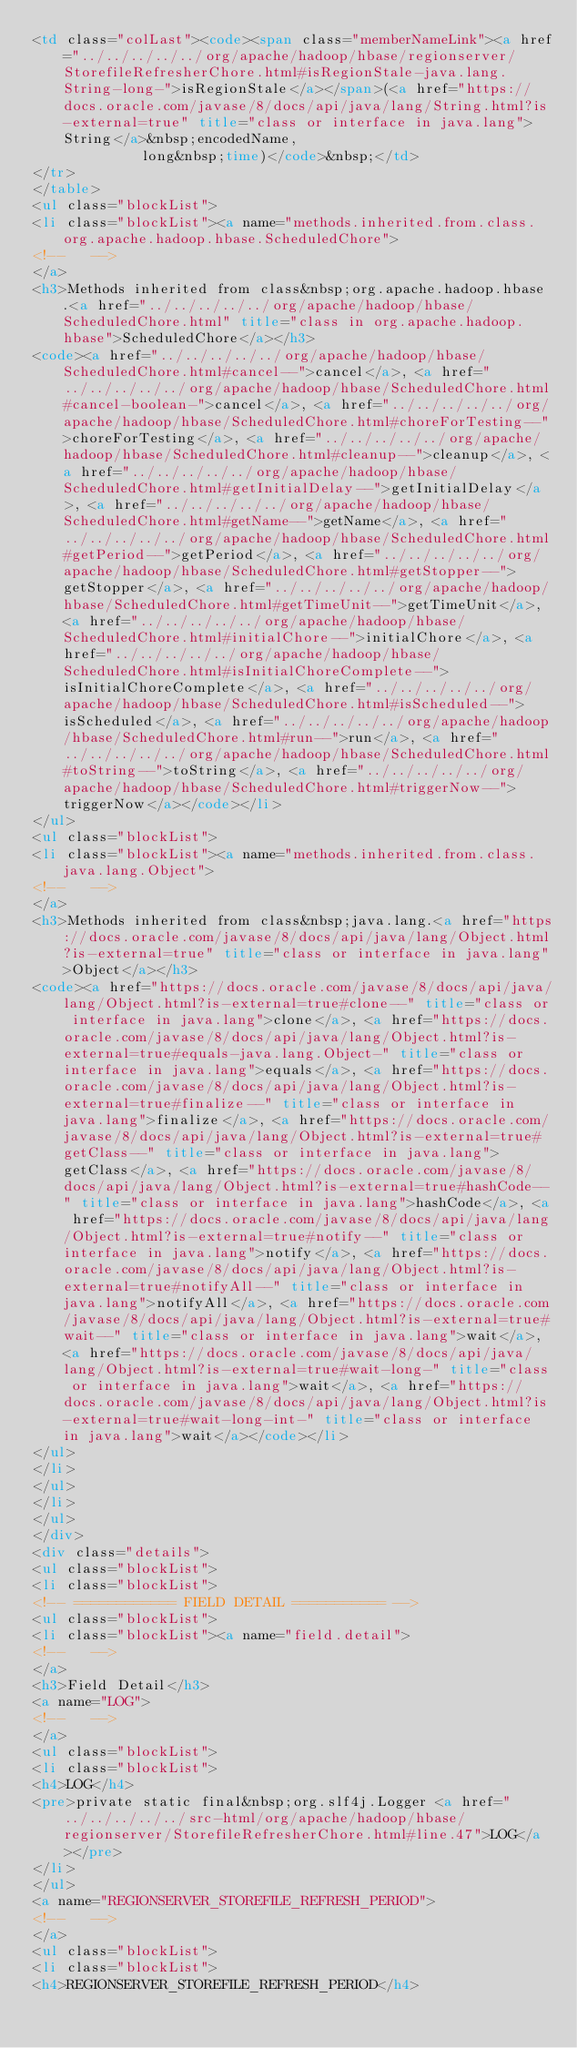<code> <loc_0><loc_0><loc_500><loc_500><_HTML_><td class="colLast"><code><span class="memberNameLink"><a href="../../../../../org/apache/hadoop/hbase/regionserver/StorefileRefresherChore.html#isRegionStale-java.lang.String-long-">isRegionStale</a></span>(<a href="https://docs.oracle.com/javase/8/docs/api/java/lang/String.html?is-external=true" title="class or interface in java.lang">String</a>&nbsp;encodedName,
             long&nbsp;time)</code>&nbsp;</td>
</tr>
</table>
<ul class="blockList">
<li class="blockList"><a name="methods.inherited.from.class.org.apache.hadoop.hbase.ScheduledChore">
<!--   -->
</a>
<h3>Methods inherited from class&nbsp;org.apache.hadoop.hbase.<a href="../../../../../org/apache/hadoop/hbase/ScheduledChore.html" title="class in org.apache.hadoop.hbase">ScheduledChore</a></h3>
<code><a href="../../../../../org/apache/hadoop/hbase/ScheduledChore.html#cancel--">cancel</a>, <a href="../../../../../org/apache/hadoop/hbase/ScheduledChore.html#cancel-boolean-">cancel</a>, <a href="../../../../../org/apache/hadoop/hbase/ScheduledChore.html#choreForTesting--">choreForTesting</a>, <a href="../../../../../org/apache/hadoop/hbase/ScheduledChore.html#cleanup--">cleanup</a>, <a href="../../../../../org/apache/hadoop/hbase/ScheduledChore.html#getInitialDelay--">getInitialDelay</a>, <a href="../../../../../org/apache/hadoop/hbase/ScheduledChore.html#getName--">getName</a>, <a href="../../../../../org/apache/hadoop/hbase/ScheduledChore.html#getPeriod--">getPeriod</a>, <a href="../../../../../org/apache/hadoop/hbase/ScheduledChore.html#getStopper--">getStopper</a>, <a href="../../../../../org/apache/hadoop/hbase/ScheduledChore.html#getTimeUnit--">getTimeUnit</a>, <a href="../../../../../org/apache/hadoop/hbase/ScheduledChore.html#initialChore--">initialChore</a>, <a href="../../../../../org/apache/hadoop/hbase/ScheduledChore.html#isInitialChoreComplete--">isInitialChoreComplete</a>, <a href="../../../../../org/apache/hadoop/hbase/ScheduledChore.html#isScheduled--">isScheduled</a>, <a href="../../../../../org/apache/hadoop/hbase/ScheduledChore.html#run--">run</a>, <a href="../../../../../org/apache/hadoop/hbase/ScheduledChore.html#toString--">toString</a>, <a href="../../../../../org/apache/hadoop/hbase/ScheduledChore.html#triggerNow--">triggerNow</a></code></li>
</ul>
<ul class="blockList">
<li class="blockList"><a name="methods.inherited.from.class.java.lang.Object">
<!--   -->
</a>
<h3>Methods inherited from class&nbsp;java.lang.<a href="https://docs.oracle.com/javase/8/docs/api/java/lang/Object.html?is-external=true" title="class or interface in java.lang">Object</a></h3>
<code><a href="https://docs.oracle.com/javase/8/docs/api/java/lang/Object.html?is-external=true#clone--" title="class or interface in java.lang">clone</a>, <a href="https://docs.oracle.com/javase/8/docs/api/java/lang/Object.html?is-external=true#equals-java.lang.Object-" title="class or interface in java.lang">equals</a>, <a href="https://docs.oracle.com/javase/8/docs/api/java/lang/Object.html?is-external=true#finalize--" title="class or interface in java.lang">finalize</a>, <a href="https://docs.oracle.com/javase/8/docs/api/java/lang/Object.html?is-external=true#getClass--" title="class or interface in java.lang">getClass</a>, <a href="https://docs.oracle.com/javase/8/docs/api/java/lang/Object.html?is-external=true#hashCode--" title="class or interface in java.lang">hashCode</a>, <a href="https://docs.oracle.com/javase/8/docs/api/java/lang/Object.html?is-external=true#notify--" title="class or interface in java.lang">notify</a>, <a href="https://docs.oracle.com/javase/8/docs/api/java/lang/Object.html?is-external=true#notifyAll--" title="class or interface in java.lang">notifyAll</a>, <a href="https://docs.oracle.com/javase/8/docs/api/java/lang/Object.html?is-external=true#wait--" title="class or interface in java.lang">wait</a>, <a href="https://docs.oracle.com/javase/8/docs/api/java/lang/Object.html?is-external=true#wait-long-" title="class or interface in java.lang">wait</a>, <a href="https://docs.oracle.com/javase/8/docs/api/java/lang/Object.html?is-external=true#wait-long-int-" title="class or interface in java.lang">wait</a></code></li>
</ul>
</li>
</ul>
</li>
</ul>
</div>
<div class="details">
<ul class="blockList">
<li class="blockList">
<!-- ============ FIELD DETAIL =========== -->
<ul class="blockList">
<li class="blockList"><a name="field.detail">
<!--   -->
</a>
<h3>Field Detail</h3>
<a name="LOG">
<!--   -->
</a>
<ul class="blockList">
<li class="blockList">
<h4>LOG</h4>
<pre>private static final&nbsp;org.slf4j.Logger <a href="../../../../../src-html/org/apache/hadoop/hbase/regionserver/StorefileRefresherChore.html#line.47">LOG</a></pre>
</li>
</ul>
<a name="REGIONSERVER_STOREFILE_REFRESH_PERIOD">
<!--   -->
</a>
<ul class="blockList">
<li class="blockList">
<h4>REGIONSERVER_STOREFILE_REFRESH_PERIOD</h4></code> 